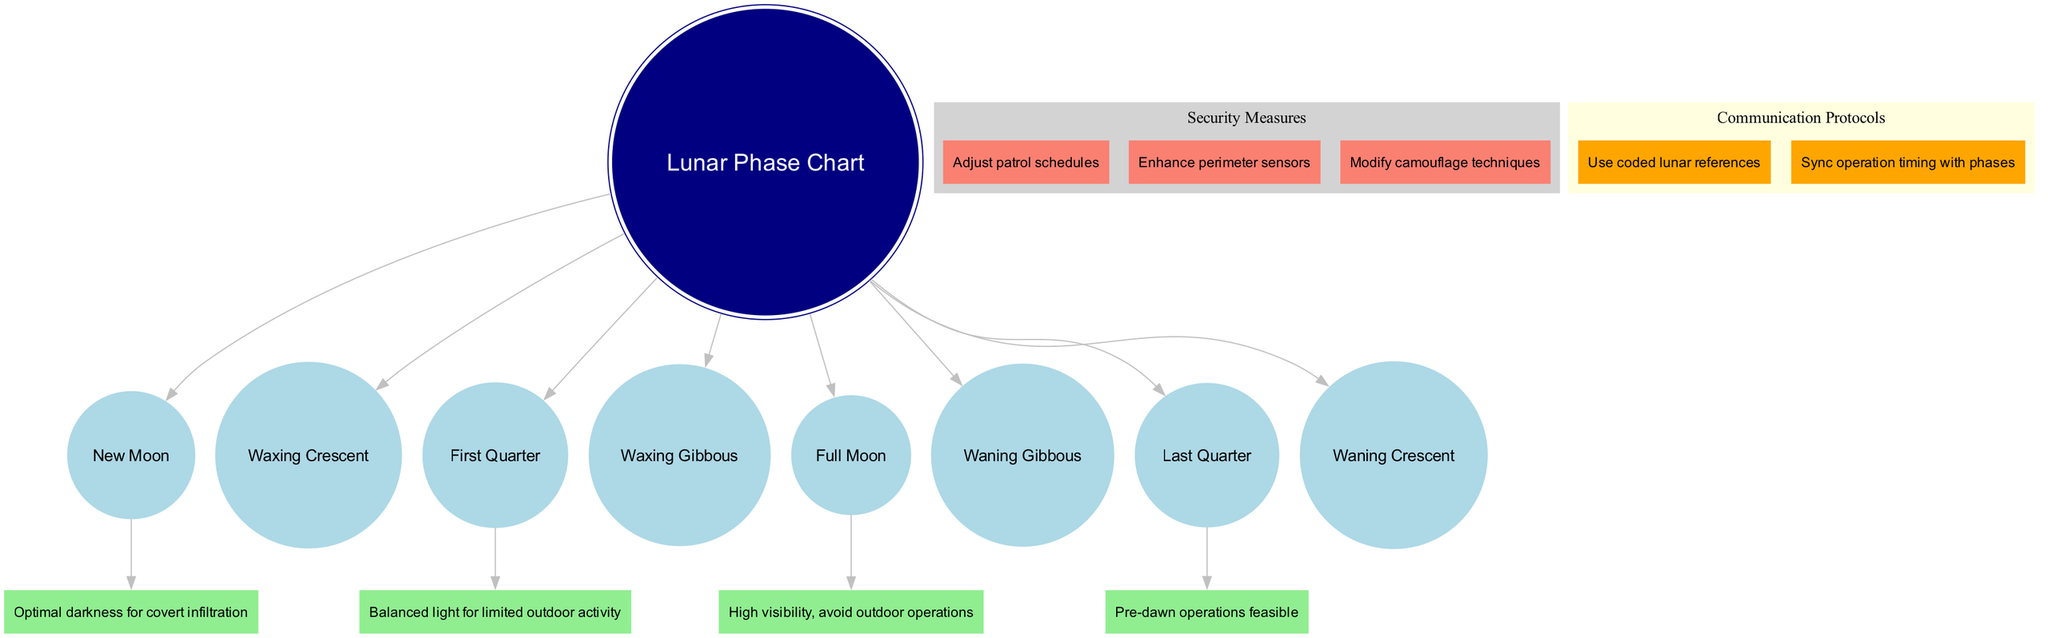What are the eight lunar phases shown in the diagram? The diagram lists the lunar phases directly as nodes stemming from the center node labeled 'Lunar Phase Chart'. These include New Moon, Waxing Crescent, First Quarter, Waxing Gibbous, Full Moon, Waning Gibbous, Last Quarter, and Waning Crescent.
Answer: New Moon, Waxing Crescent, First Quarter, Waxing Gibbous, Full Moon, Waning Gibbous, Last Quarter, Waning Crescent Which lunar phase is associated with "Optimal darkness for covert infiltration"? The operational consideration is specifically linked to the 'New Moon' phase, as indicated by the edge connecting 'New Moon' to its corresponding consideration node.
Answer: New Moon How many nodes represent operational considerations in the diagram? There are a total of four operational considerations nodes that are connected to their respective lunar phases, based on the provided operational considerations data.
Answer: 4 What is the security measure mentioned in the diagram? The diagram lists three security measures within the 'Security Measures' cluster, with the first one being 'Adjust patrol schedules', clearly displaying that this is part of the operational security approach.
Answer: Adjust patrol schedules Which lunar phase is deemed appropriate for "Pre-dawn operations feasible"? The consideration is directly linked to the 'Last Quarter' phase within the operational considerations section of the diagram, indicating that this phase is suitable for such operations.
Answer: Last Quarter What color represents the security measures nodes in the diagram? The security measures are denoted in 'salmon' color as specified in the node attributes for the 'Security Measures' cluster.
Answer: Salmon What coded strategy is suggested for communication protocols? The communication protocols include the suggestion to 'Use coded lunar references', which is shown as one of the nodes under the 'Communication Protocols' cluster in the diagram.
Answer: Use coded lunar references How many lunar phases are associated with operational considerations? Only four phases have specific operational considerations attached to them in the diagram: New Moon, Full Moon, First Quarter, and Last Quarter, which directly corresponds to the data provided.
Answer: 4 What do the edges connecting the phases to their considerations represent? The edges represent the relationship between the lunar phases and their specific operational considerations, indicating how each phase impacts operational planning.
Answer: Relationships between phases and considerations 